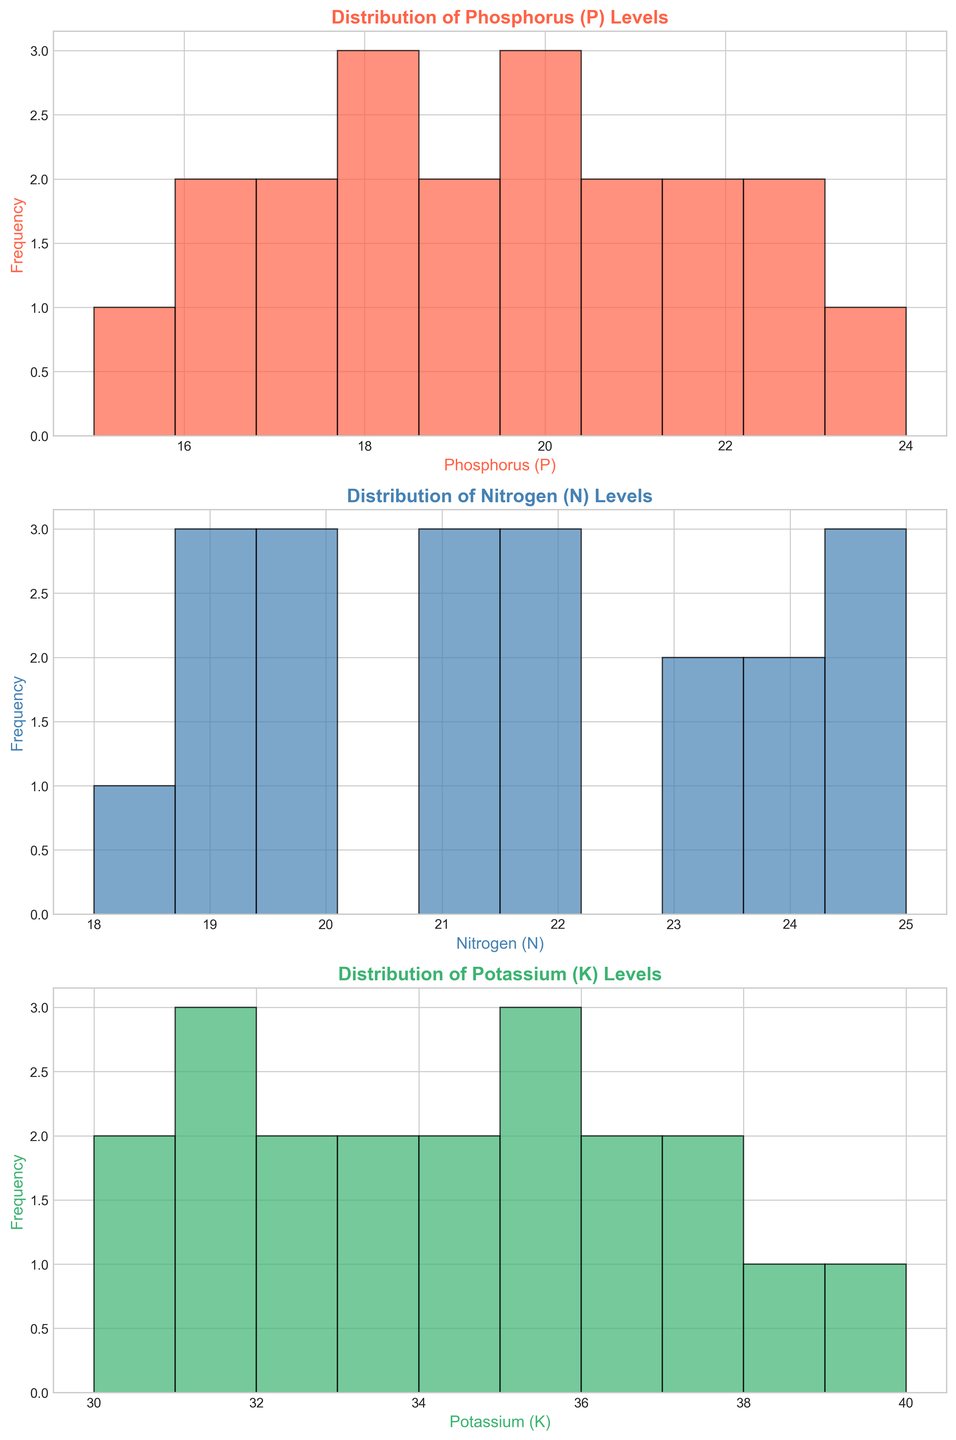What is the most frequent range of Phosphorus (P) levels? Look at the histogram for Phosphorus (P) levels and identify the bin (range) that contains the highest number of data points (bars).
Answer: 15-17 Which nutrient has the widest distribution range? Compare the range (difference between the highest and lowest values) of the distributions for Phosphorus (P), Nitrogen (N), and Potassium (K) by checking the span of the x-axis for each histogram.
Answer: Nitrogen (N) In which histogram do the bars appear the tallest, indicating the most frequent nutrient level range? Visually inspect the height of the bars across the three histograms to determine which set of bars rises the highest.
Answer: Phosphorus (P) What is the median level of Potassium (K)? To determine the median, sort the Potassium (K) values and find the middle number. For an even amount of data (20 values), the median is the average of the 10th and 11th values. (Values sorted: 30, 30, 31, 31, 31, 31, 32, 32, 32, 32, 33, 33, 34, 34, 34, 35, 35, 35, 36, 37).
Answer: 32.5 How do the median levels of Nitrogen (N) and Potassium (K) compare? First, find the median level for each nutrient. Then, compare these values to see which is higher. Median of Nitrogen (N) is 21. Median of Potassium (K) is 32.5.
Answer: Potassium (K) is higher Which nutrient has the most consistent levels across different plots? Identify the histogram with the narrowest distribution range, which implies less variation. Compare the range for Phosphorus (P), Nitrogen (N), and Potassium (K).
Answer: Phosphorus (P) What is the difference between the highest and lowest recorded Phosphorus (P) levels? Examine the Phosphorus (P) histogram to identify the highest and lowest data points. Subtract the smallest value from the largest value. The range is from 15 to 24.
Answer: 9 Among the three nutrients, which one has both high frequency and wide range of levels? Evaluate which histogram indicates a high frequency of occurrence (tall bars) and also displays a wide range of data values (spread across the x-axis).
Answer: Nitrogen (N) What is the average Nitrogen (N) level across all plots? Sum all the Nitrogen (N) values and divide by the number of plots (20). The sum is 414. Divide by 20 plots.
Answer: 20.7 Which bin range appears most frequently for Potassium (K) levels? Look at the histogram for Potassium (K) and identify the bin that has the highest frequency bar.
Answer: 31-33 